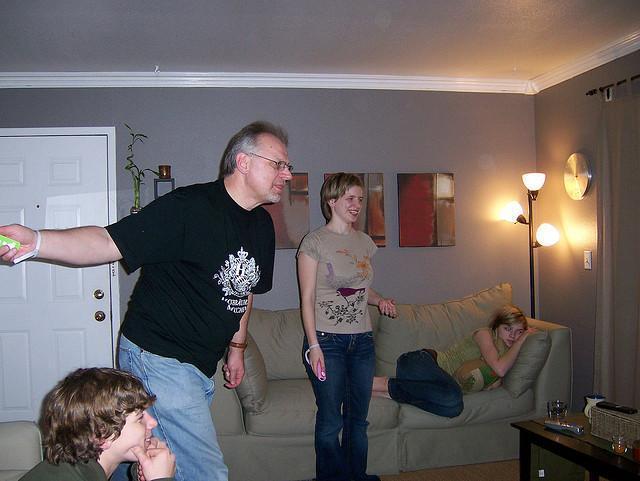How many persons are wearing glasses?
Give a very brief answer. 1. How many people can be seen?
Give a very brief answer. 4. 